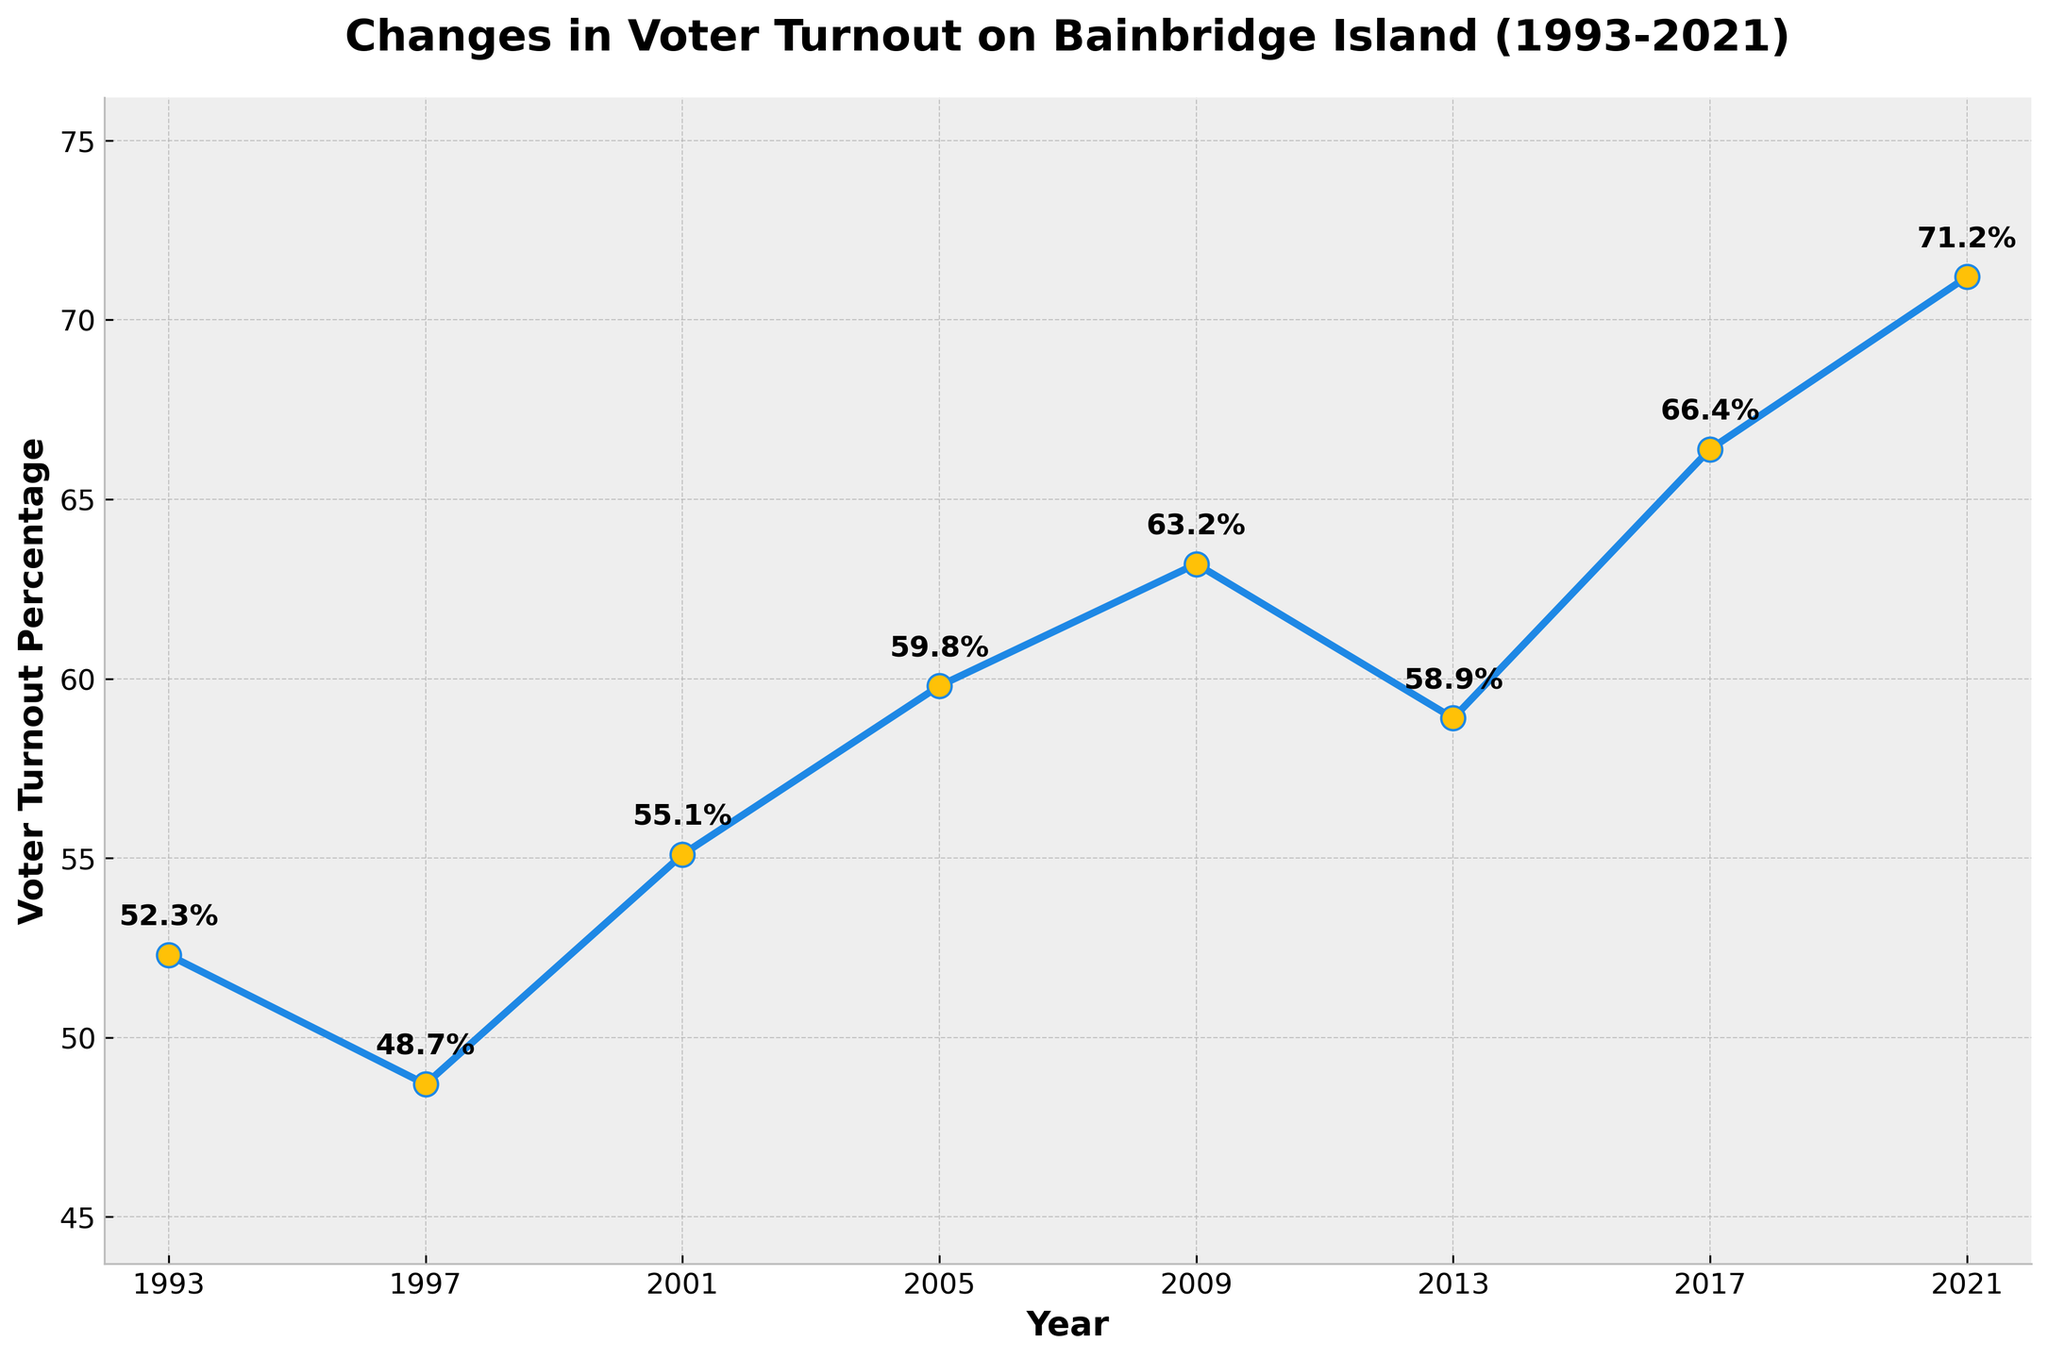What was the voter turnout percentage in 2005? To find the voter turnout percentage for 2005, locate the value corresponding to the year 2005 on the chart. The marker for 2005 denotes a voter turnout of 59.8%.
Answer: 59.8% Between which consecutive years was the largest increase in voter turnout? Check the differences in voter turnout percentages between consecutive years. The increase from 2017 (66.4%) to 2021 (71.2%) is the largest, a difference of 71.2 - 66.4 = 4.8%.
Answer: 2017 and 2021 What is the average voter turnout percentage for the years shown? Sum the voter turnout percentages for all years and divide by the number of years. (52.3 + 48.7 + 55.1 + 59.8 + 63.2 + 58.9 + 66.4 + 71.2)/8 = 59.5%
Answer: 59.5% In which year did the voter turnout percentage first exceed 60%? Look at the markers for each year to identify when the turnout first exceeds 60%. This happens in 2009 with a turnout of 63.2%.
Answer: 2009 How many years had a voter turnout percentage less than 55%? Count the years where the voter turnout percentage is below 55%. This occurs in 1997 (48.7%) and 1993 (52.3%). So there are 2 years.
Answer: 2 How much did the voter turnout percentage change from 1993 to 2021? Subtract the 1993 voter turnout (52.3%) from the 2021 voter turnout (71.2%). 71.2 - 52.3 = 18.9%
Answer: 18.9% Compare the voter turnout percentage in 2013 to that in 2017. Which year had a higher turnout? Compare the values: 2013 had a turnout of 58.9%, whereas 2017 had 66.4%. Therefore, 2017 had a higher turnout.
Answer: 2017 What's the difference in voter turnout percentage between 2001 and 2005? Subtract the 2001 voter turnout (55.1%) from the 2005 voter turnout (59.8%). 59.8 - 55.1 = 4.7%
Answer: 4.7% Which two years have the closest voter turnout percentages? Calculate the differences between consecutive years and find the smallest difference. The closest percentages are between 2013 (58.9%) and 2005 (59.8%), with a difference of 59.8 - 58.9 = 0.9%.
Answer: 2013 and 2005 Is the voter turnout trend generally increasing, decreasing, or fluctuating over the 30 years? Observe the trend of voter turnout across the entire period. The overall trend shows a steady increase despite some fluctuations.
Answer: Increasing 